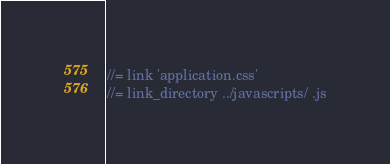<code> <loc_0><loc_0><loc_500><loc_500><_JavaScript_>//= link 'application.css'
//= link_directory ../javascripts/ .js
</code> 